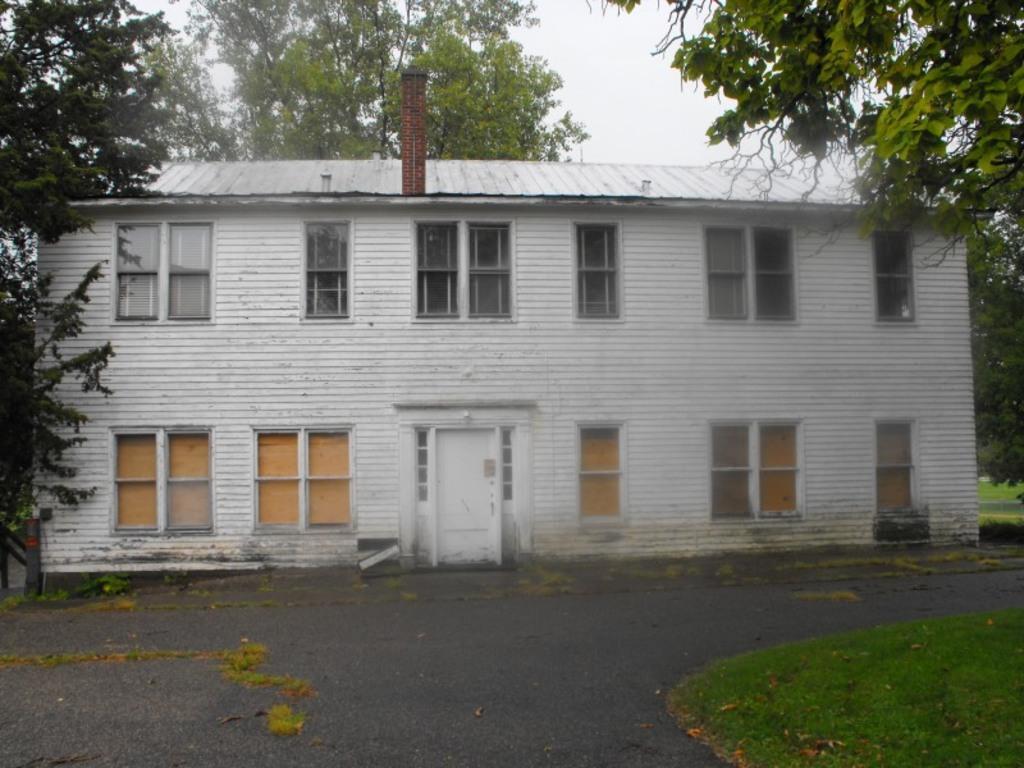In one or two sentences, can you explain what this image depicts? In the picture there is a building, it has many windows and around the building there are a lot of trees and there is a road in front of the building. 